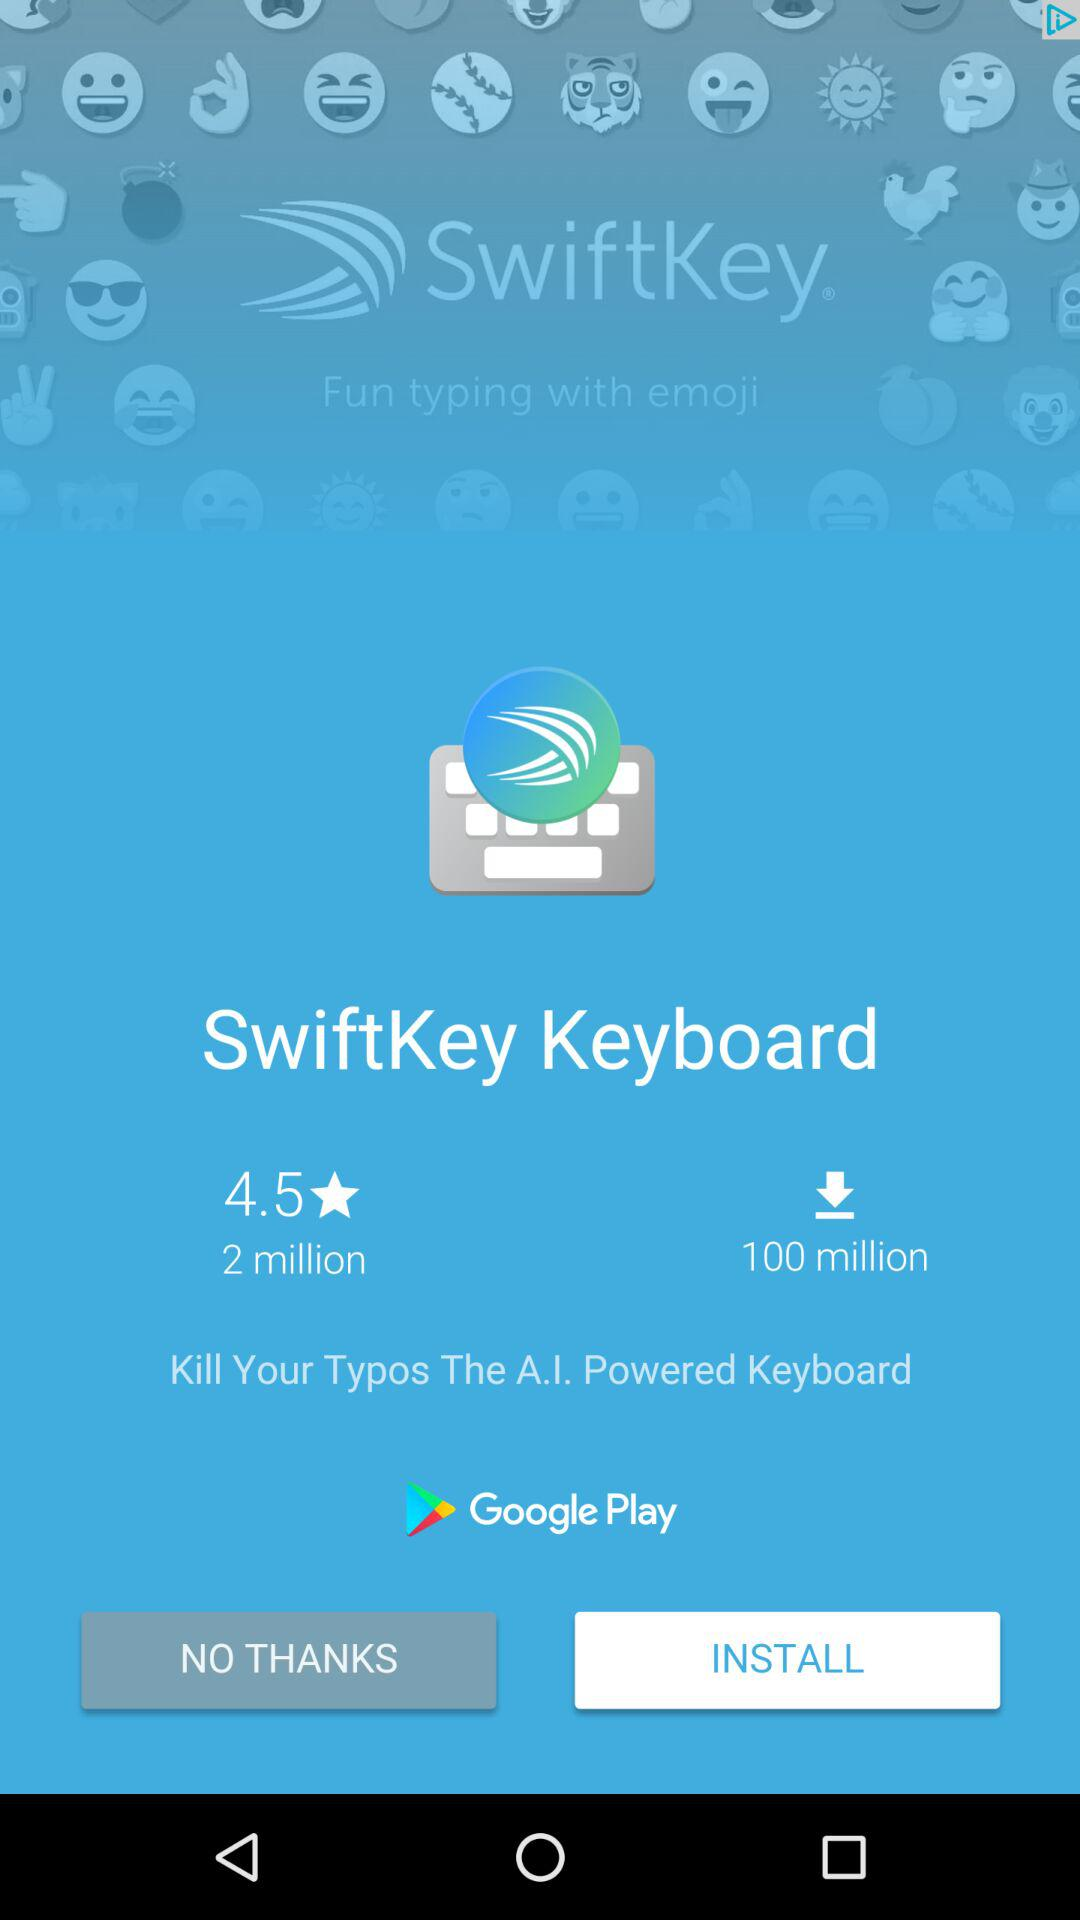What is the average rating of SwiftKey?
Answer the question using a single word or phrase. 4.5 